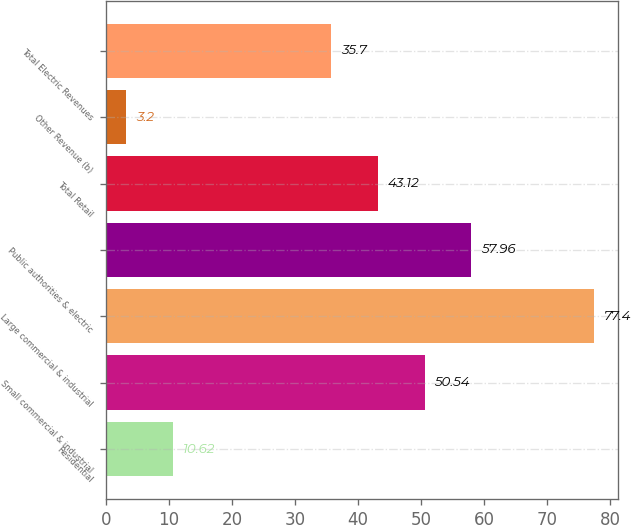Convert chart. <chart><loc_0><loc_0><loc_500><loc_500><bar_chart><fcel>Residential<fcel>Small commercial & industrial<fcel>Large commercial & industrial<fcel>Public authorities & electric<fcel>Total Retail<fcel>Other Revenue (b)<fcel>Total Electric Revenues<nl><fcel>10.62<fcel>50.54<fcel>77.4<fcel>57.96<fcel>43.12<fcel>3.2<fcel>35.7<nl></chart> 